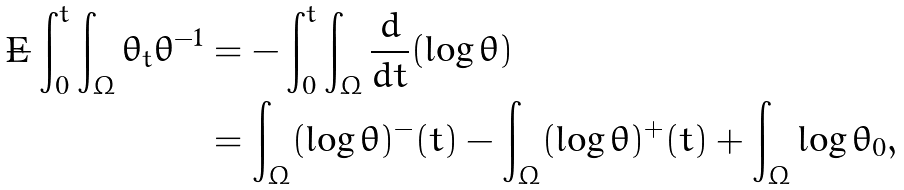<formula> <loc_0><loc_0><loc_500><loc_500>- \int _ { 0 } ^ { t } \int _ { \Omega } \theta _ { t } \theta ^ { - 1 } & = - \int _ { 0 } ^ { t } \int _ { \Omega } \frac { d } { d t } ( \log \theta ) \\ & = \int _ { \Omega } ( \log \theta ) ^ { - } ( t ) - \int _ { \Omega } ( \log \theta ) ^ { + } ( t ) + \int _ { \Omega } \log \theta _ { 0 } ,</formula> 